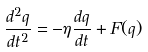Convert formula to latex. <formula><loc_0><loc_0><loc_500><loc_500>\frac { d ^ { 2 } q } { d t ^ { 2 } } = - \eta \frac { d q } { d t } + F ( q )</formula> 